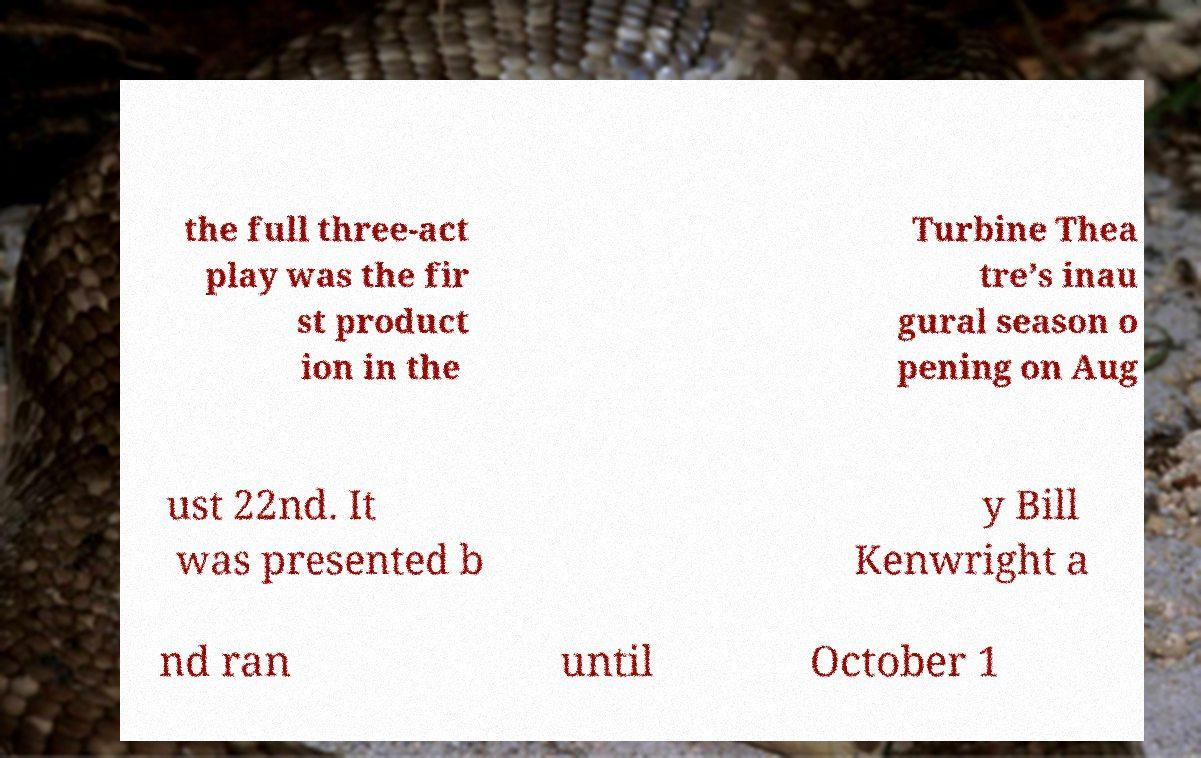What messages or text are displayed in this image? I need them in a readable, typed format. the full three-act play was the fir st product ion in the Turbine Thea tre’s inau gural season o pening on Aug ust 22nd. It was presented b y Bill Kenwright a nd ran until October 1 